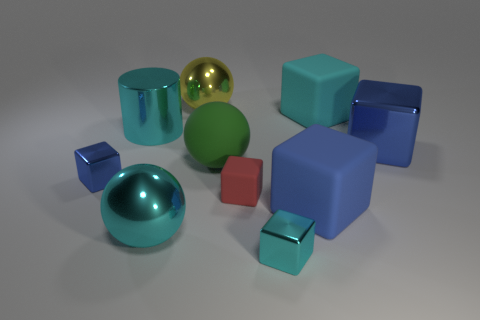What shape is the cyan rubber thing that is the same size as the green sphere?
Give a very brief answer. Cube. How many objects are yellow metallic objects or tiny objects right of the big yellow metallic ball?
Offer a terse response. 3. Do the tiny matte block and the metal cylinder have the same color?
Make the answer very short. No. How many big blue rubber objects are left of the tiny cyan shiny thing?
Give a very brief answer. 0. The big cylinder that is the same material as the cyan sphere is what color?
Offer a very short reply. Cyan. What number of matte things are tiny yellow cubes or blue cubes?
Your response must be concise. 1. Does the tiny blue object have the same material as the small red object?
Your answer should be compact. No. There is a small red thing in front of the cylinder; what is its shape?
Your answer should be very brief. Cube. Is there a green object that is on the right side of the cyan object that is right of the tiny cyan metal thing?
Your answer should be compact. No. Is there a gray matte cylinder of the same size as the red cube?
Make the answer very short. No. 